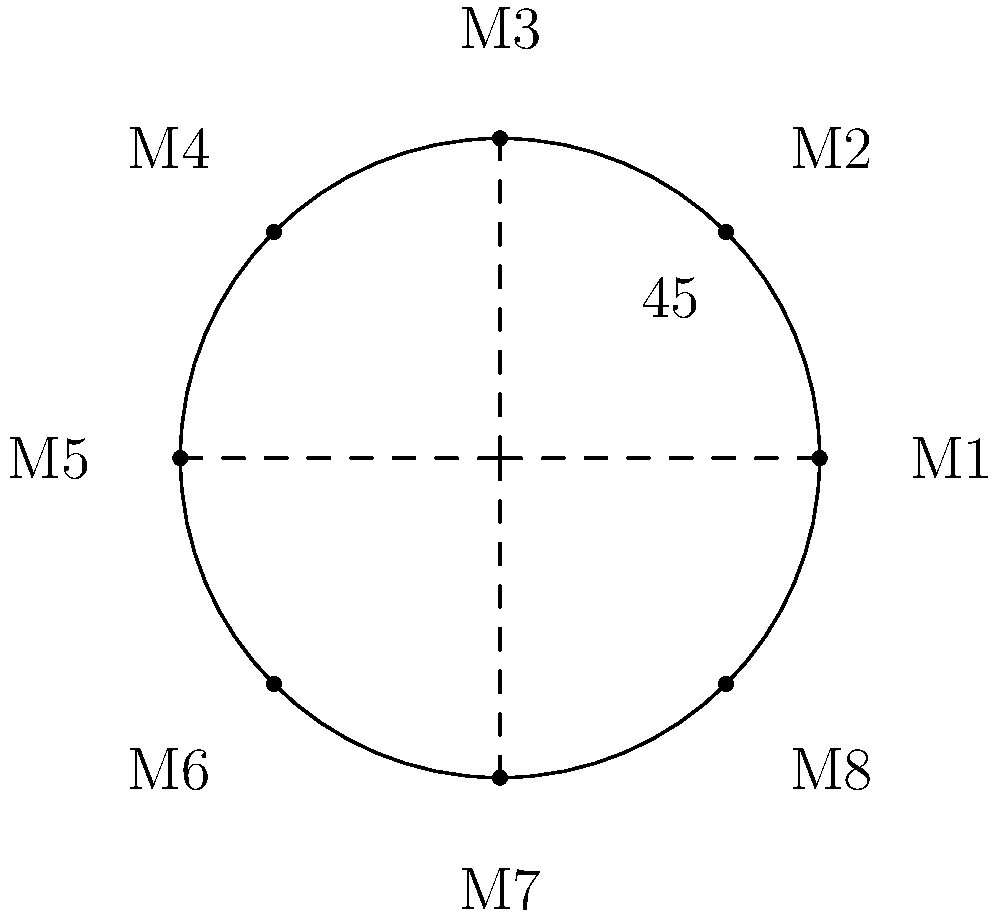In a circular apartment complex lobby, 8 mailboxes are arranged evenly around the perimeter. If the first mailbox (M1) is positioned at 0°, what is the angle between each consecutive mailbox? To find the angle between consecutive mailboxes, we can follow these steps:

1. Recognize that the mailboxes are evenly spaced around a full circle.
2. Recall that a full circle contains 360°.
3. Count the total number of mailboxes: 8.
4. To find the angle between each mailbox, divide the total degrees in a circle by the number of mailboxes:

   $$\text{Angle between mailboxes} = \frac{360°}{8} = 45°$$

5. Verify: If we multiply this angle by the number of mailboxes, we should get a full circle:
   $$45° \times 8 = 360°$$

This confirms that 45° is the correct angle between consecutive mailboxes.
Answer: 45° 